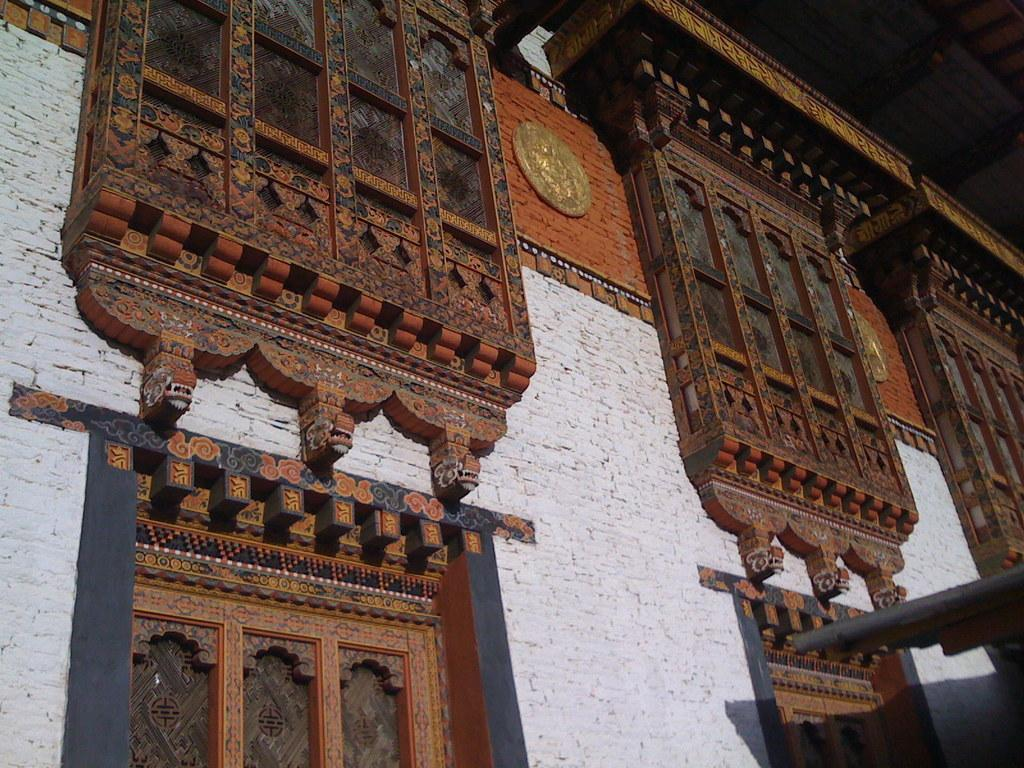What is present on the wall in the image? There are wooden boards on the wall. What is placed on the wooden boards? There is an art piece and other objects on the wooden boards. Can you describe the art piece on the wooden boards? Unfortunately, the specific details of the art piece cannot be determined from the provided facts. What might be visible at the top of the image? The top of the image might include a ceiling. How many cherries are hanging from the uncle's house in the image? There is no mention of cherries, an uncle, or a house in the provided facts, so this question cannot be answered. 